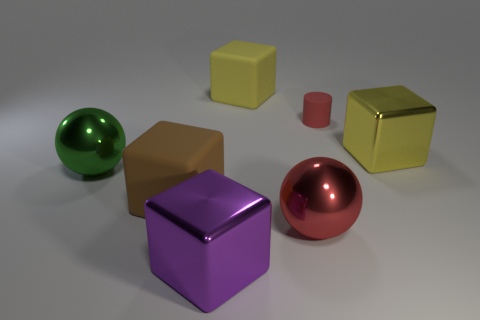Is there anything in the image that suggests size or scale? There are no obvious reference objects to accurately determine the absolute size of the shapes, but their relative sizes to one another suggest a mid-range scale, likely meant to be perceived as commonly sized objects such as those that might be held in a hand. 